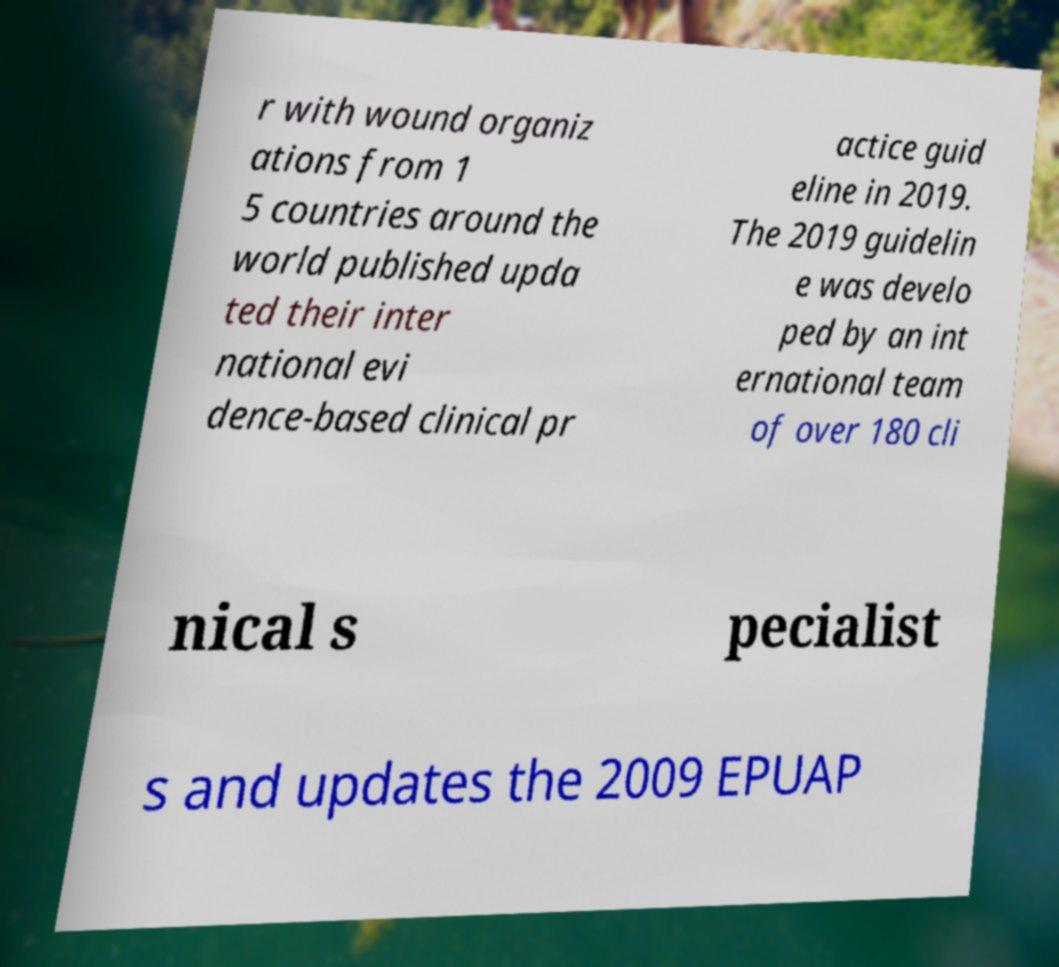There's text embedded in this image that I need extracted. Can you transcribe it verbatim? r with wound organiz ations from 1 5 countries around the world published upda ted their inter national evi dence-based clinical pr actice guid eline in 2019. The 2019 guidelin e was develo ped by an int ernational team of over 180 cli nical s pecialist s and updates the 2009 EPUAP 